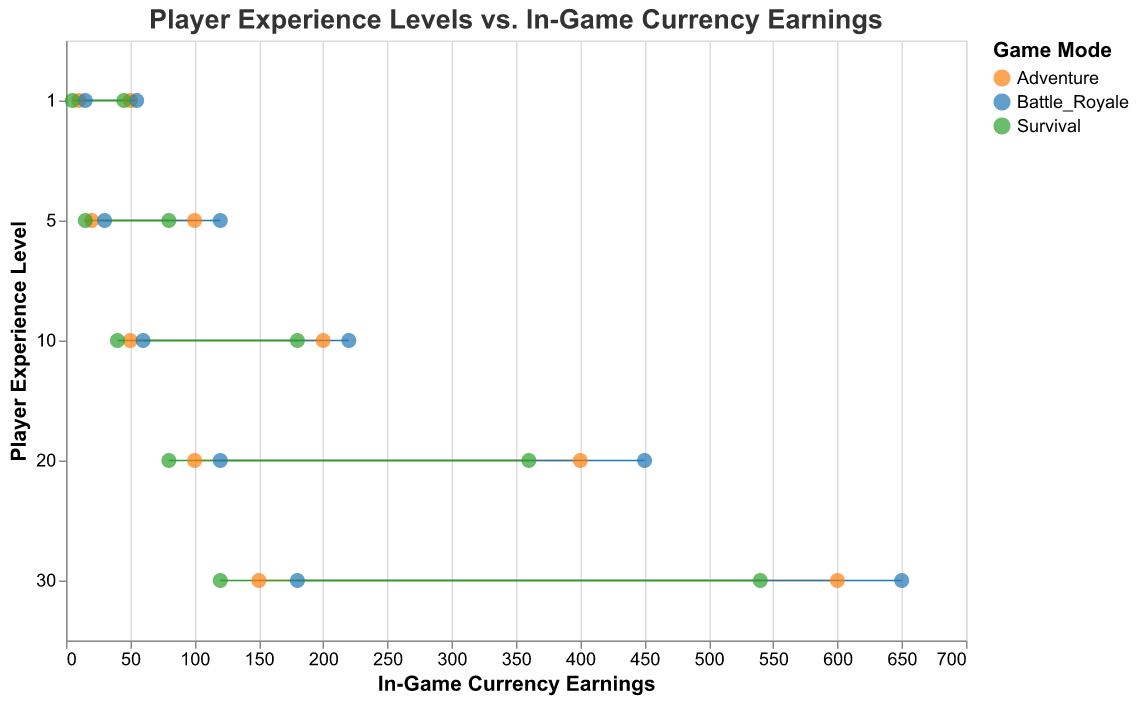What is the title of the figure? The title is displayed at the top of the figure and reads "Player Experience Levels vs. In-Game Currency Earnings".
Answer: Player Experience Levels vs. In-Game Currency Earnings What is the highest possible in-game currency earning for a player at level 30 in Battle Royale mode? Locate the Player Level 30 and Game Mode "Battle Royale", and check the Max Earnings value which appears to be the farthest point to the right.
Answer: 650 How does the minimum earning in Survival mode compare between player levels 1 and 5? Find the "Survival" game mode for player levels 1 and 5, then compare the Min Earnings values. Level 1 has 5 and Level 5 has 15.
Answer: 5 for level 1, 15 for level 5 What is the average of minimum earnings for a level 20 player across all game modes? Find all Min Earnings for level 20 (100, 120, 80), then calculate the average: (100 + 120 + 80)/3.
Answer: 100 Which game mode shows the largest range of currency earnings for level 10 players? Calculate the range by subtracting Min Earnings from Max Earnings for each game mode at level 10. The ranges are 150 for Adventure (200-50), 160 for Battle Royale (220-60), and 140 for Survival (180-40).
Answer: Battle Royale Which game mode has the smallest difference between Min and Max Earnings for players at level 1? Compare the ranges for level 1: Adventure (50-10 = 40), Battle Royale (55-15 = 40), and Survival (45-5 = 40). All ranges are the same.
Answer: All modes have the same range Is there a trend in earnings as player levels increase? Observe the overall trends of Min and Max Earnings as Player Levels increase from 1 to 30. Both minimum and maximum earnings increase with higher player levels.
Answer: Earnings increase with player levels What game mode has the highest minimum earnings for a level 30 player? Check the Min Earnings for level 30 players in each game mode: Adventure (150), Battle Royale (180), and Survival (120).
Answer: Battle Royale Compare the maximum earnings in Adventure mode between player levels 20 and 30? Check the Max Earnings for Adventure mode for levels 20 (400) and 30 (600) and compare them.
Answer: 200 more for level 30 